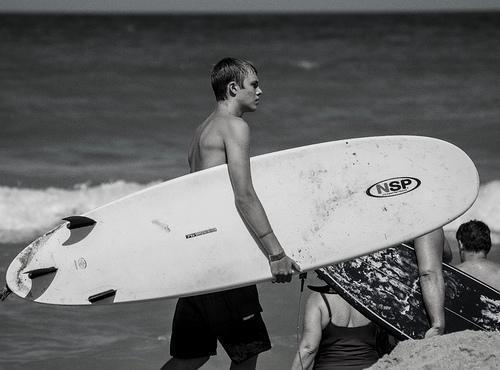How many fins are on the white surfboard?
Give a very brief answer. 3. 